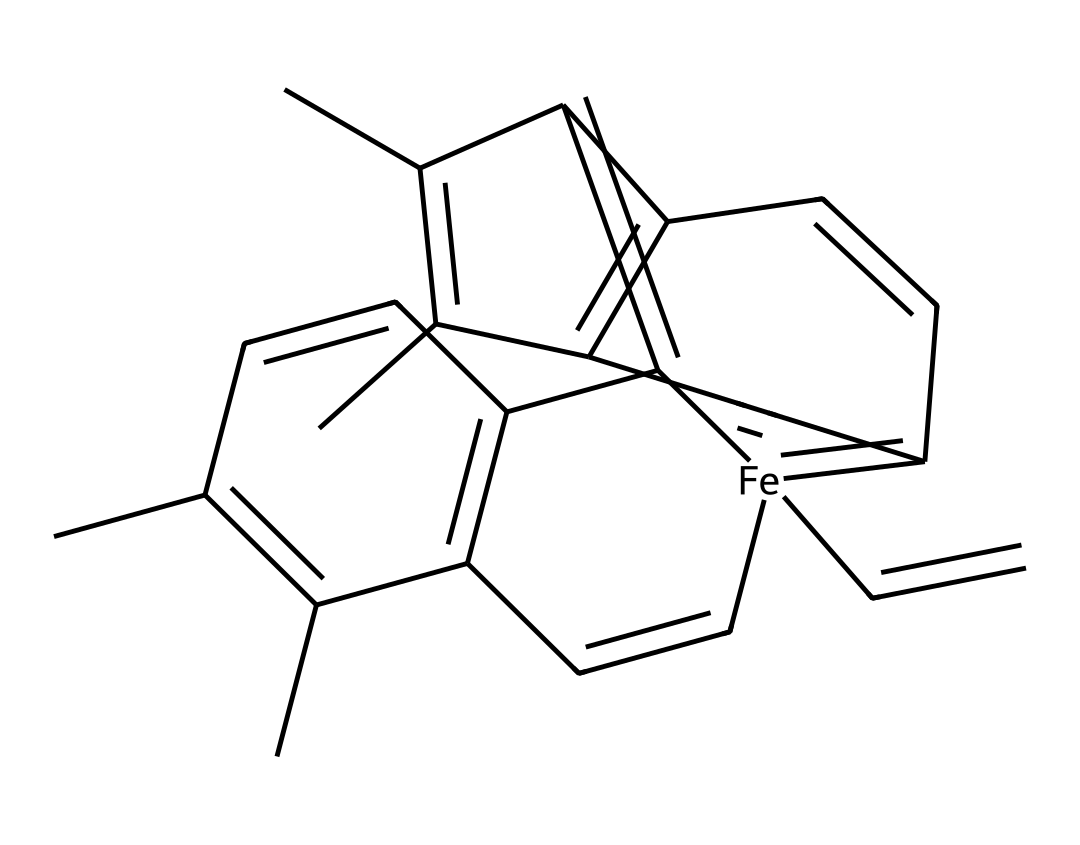What is the central metal atom in this coordination complex? The structure indicates the presence of an iron atom (Fe) at the center of the coordination complex, crucial for hemoglobin's function.
Answer: iron How many carbon atoms are present in the structure? By counting the carbon atoms in the given SMILES representation and considering each carbon symbol, there are 20 carbon atoms in total.
Answer: 20 What type of bond connects the iron to the surrounding ligands? In coordination complexes like hemoglobin, the iron forms coordinate covalent bonds with the surrounding ligands, specifically the nitrogen atoms from the heme groups.
Answer: coordinate covalent What is the oxidation state of the iron in this complex? Hemoglobin typically features iron in the +2 oxidation state (ferrous form) when it binds oxygen, as determined by the overall charge and bonding environment.
Answer: +2 Which component of hemoglobin directly binds to oxygen? The heme group, which contains the iron atom, directly participates in oxygen binding due to iron's ability to form coordination bonds with oxygen molecules.
Answer: heme group What role do the ligands play in this coordination complex? The ligands, such as the nitrogen from histidine residues, stabilize the iron's oxidation state and facilitate its ability to bind oxygen, crucial for respiratory function.
Answer: stabilize How does the structure of this coordination complex influence its function in oxygen transport? The arrangement and bonding of the iron within the heme group allow for reversible oxygen binding, essential for hemoglobin's function in transporting oxygen in the blood.
Answer: reversible oxygen binding 